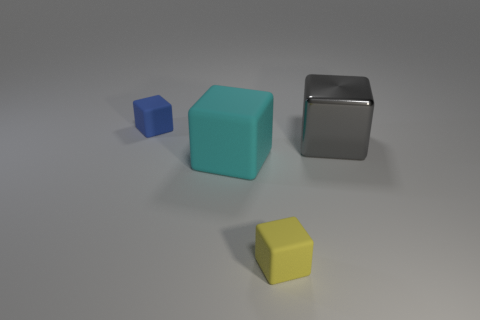Add 1 big gray cylinders. How many objects exist? 5 Subtract all small green metallic cylinders. Subtract all matte cubes. How many objects are left? 1 Add 4 big matte cubes. How many big matte cubes are left? 5 Add 3 rubber blocks. How many rubber blocks exist? 6 Subtract 0 red cubes. How many objects are left? 4 